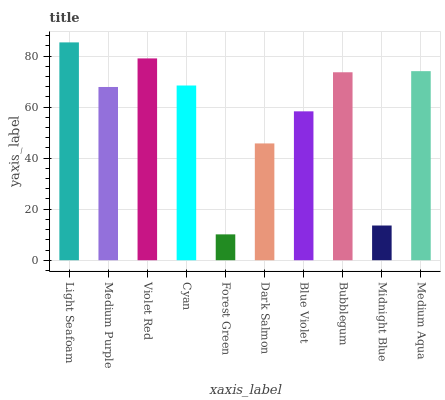Is Forest Green the minimum?
Answer yes or no. Yes. Is Light Seafoam the maximum?
Answer yes or no. Yes. Is Medium Purple the minimum?
Answer yes or no. No. Is Medium Purple the maximum?
Answer yes or no. No. Is Light Seafoam greater than Medium Purple?
Answer yes or no. Yes. Is Medium Purple less than Light Seafoam?
Answer yes or no. Yes. Is Medium Purple greater than Light Seafoam?
Answer yes or no. No. Is Light Seafoam less than Medium Purple?
Answer yes or no. No. Is Cyan the high median?
Answer yes or no. Yes. Is Medium Purple the low median?
Answer yes or no. Yes. Is Dark Salmon the high median?
Answer yes or no. No. Is Violet Red the low median?
Answer yes or no. No. 